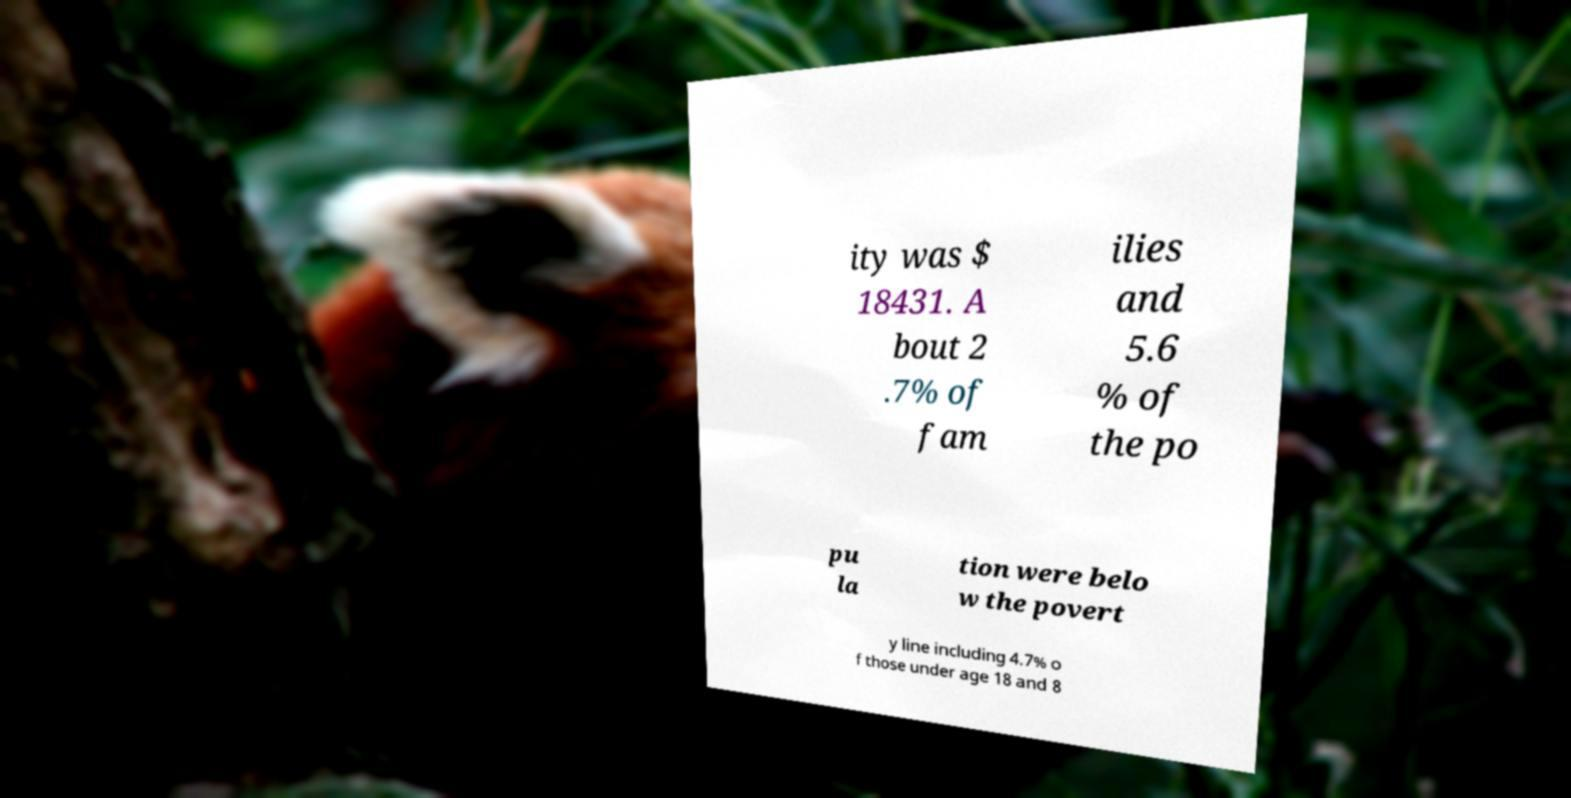For documentation purposes, I need the text within this image transcribed. Could you provide that? ity was $ 18431. A bout 2 .7% of fam ilies and 5.6 % of the po pu la tion were belo w the povert y line including 4.7% o f those under age 18 and 8 